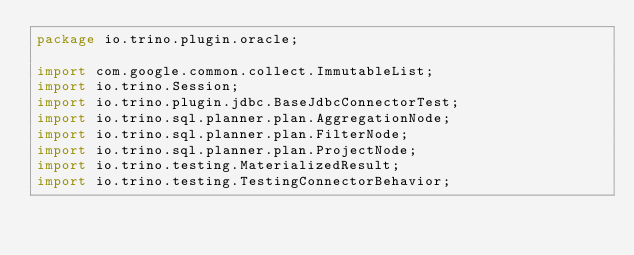Convert code to text. <code><loc_0><loc_0><loc_500><loc_500><_Java_>package io.trino.plugin.oracle;

import com.google.common.collect.ImmutableList;
import io.trino.Session;
import io.trino.plugin.jdbc.BaseJdbcConnectorTest;
import io.trino.sql.planner.plan.AggregationNode;
import io.trino.sql.planner.plan.FilterNode;
import io.trino.sql.planner.plan.ProjectNode;
import io.trino.testing.MaterializedResult;
import io.trino.testing.TestingConnectorBehavior;</code> 